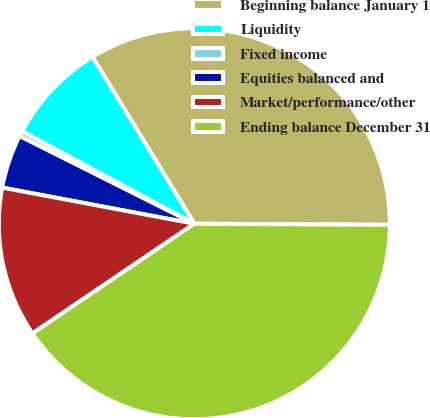Convert chart to OTSL. <chart><loc_0><loc_0><loc_500><loc_500><pie_chart><fcel>Beginning balance January 1<fcel>Liquidity<fcel>Fixed income<fcel>Equities balanced and<fcel>Market/performance/other<fcel>Ending balance December 31<nl><fcel>33.81%<fcel>8.44%<fcel>0.44%<fcel>4.44%<fcel>12.44%<fcel>40.44%<nl></chart> 